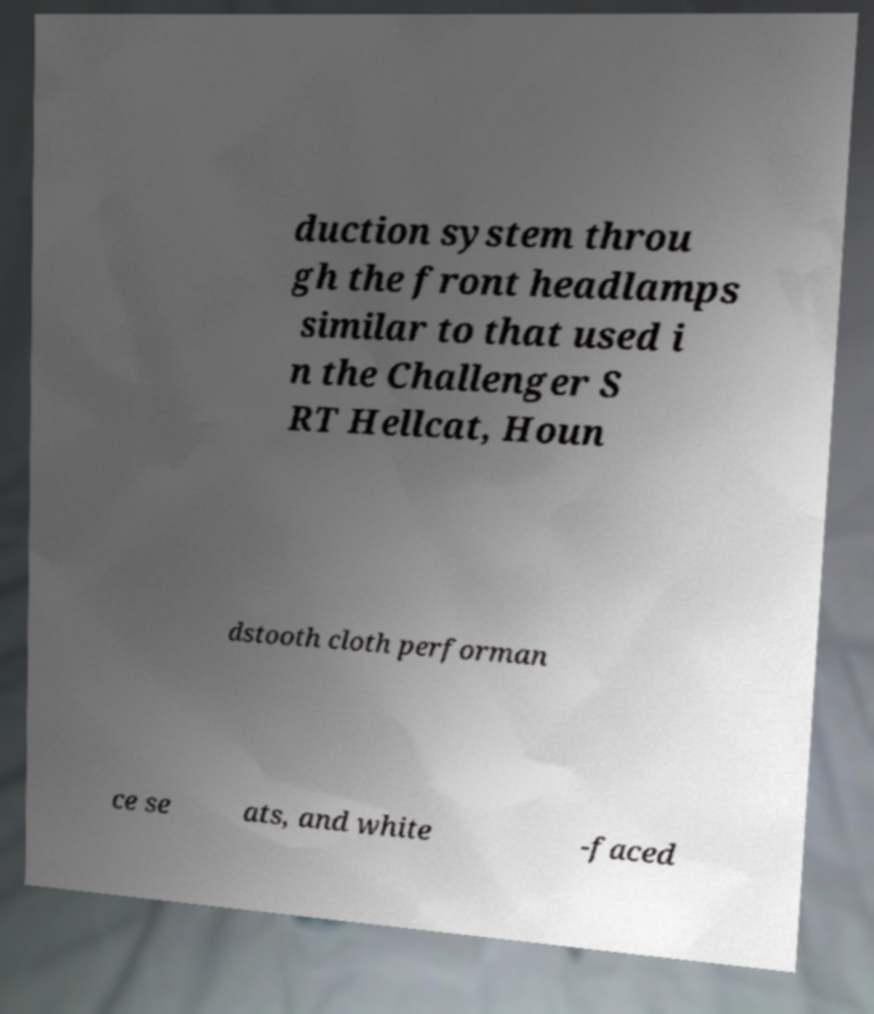Please read and relay the text visible in this image. What does it say? duction system throu gh the front headlamps similar to that used i n the Challenger S RT Hellcat, Houn dstooth cloth performan ce se ats, and white -faced 